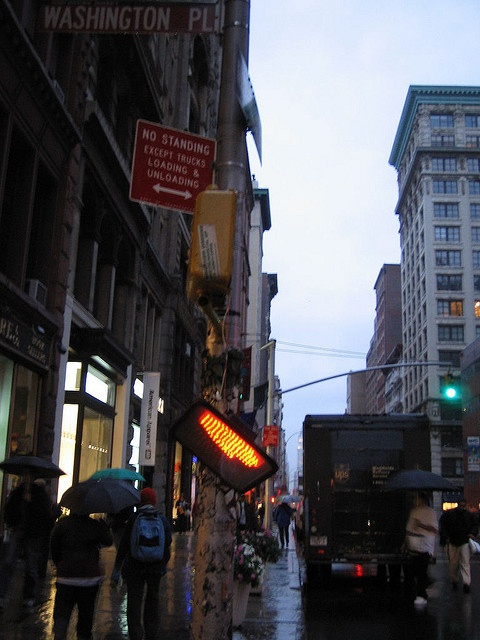Describe the objects in this image and their specific colors. I can see bus in black, navy, gray, and maroon tones, truck in black, navy, gray, and maroon tones, people in black, navy, maroon, and darkblue tones, people in black and olive tones, and people in black and gray tones in this image. 